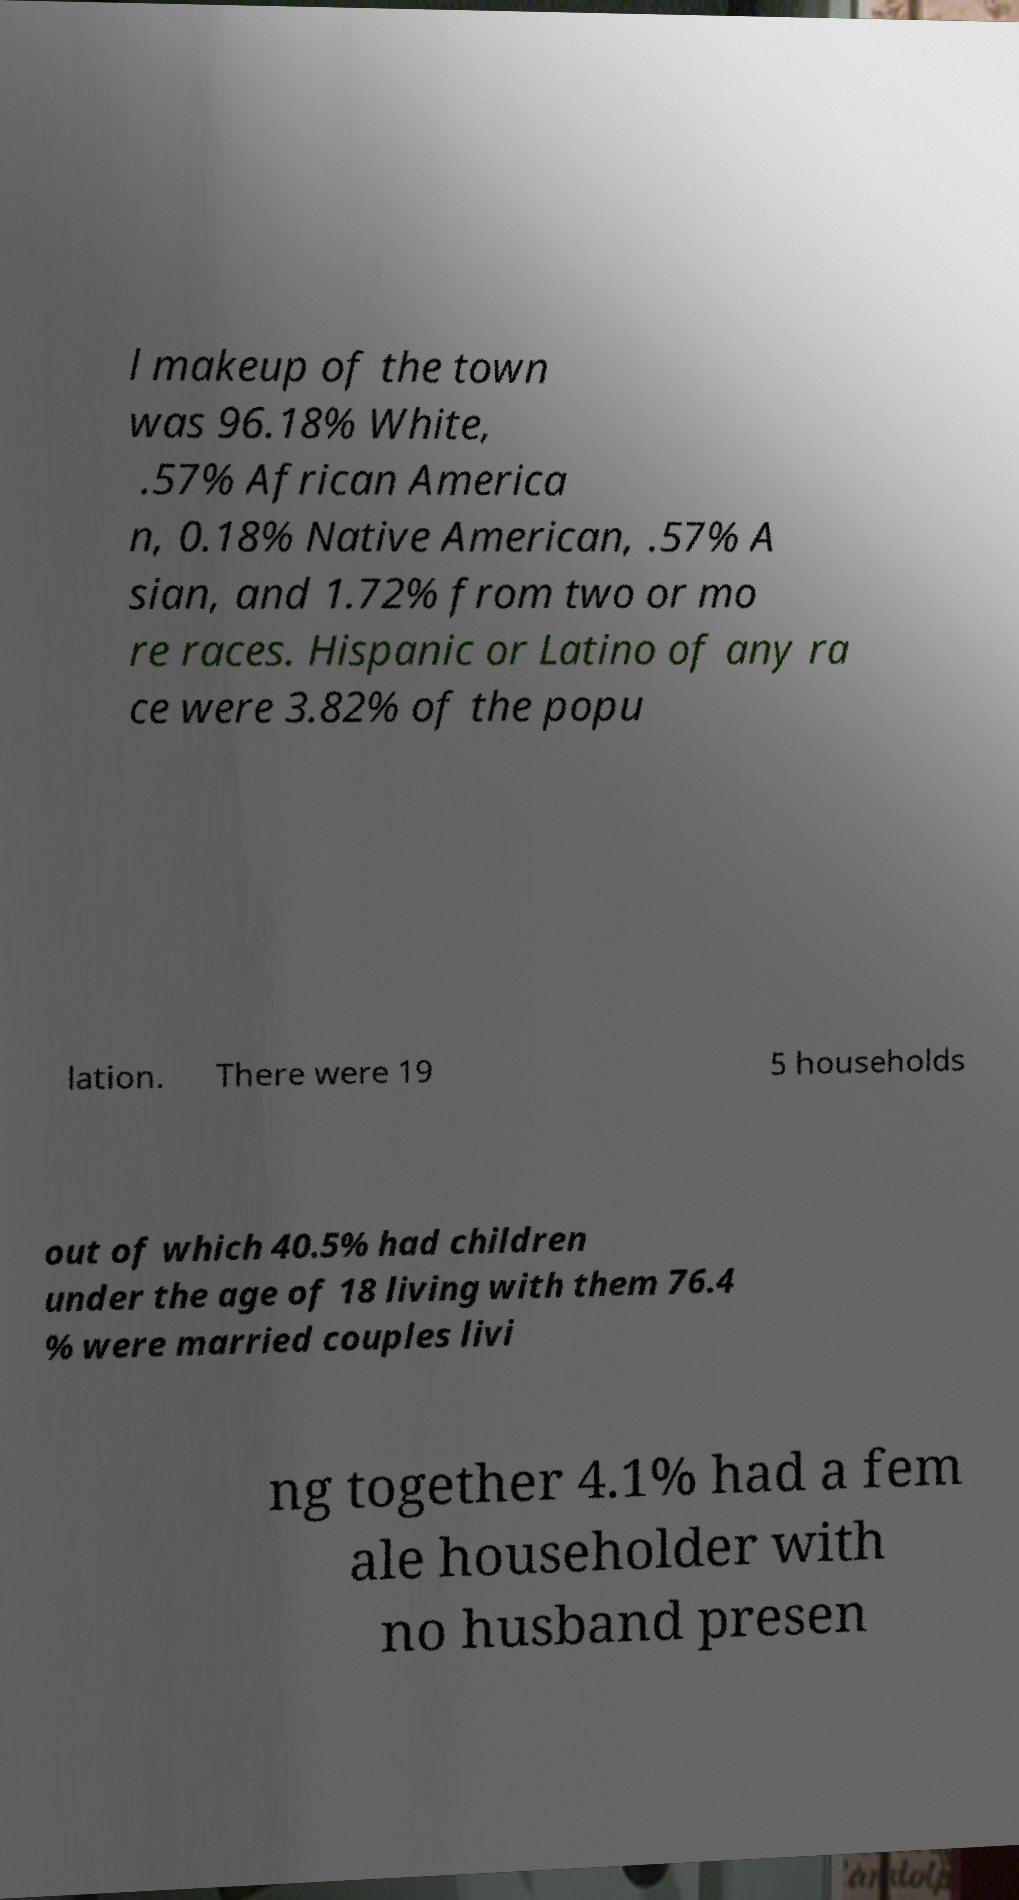I need the written content from this picture converted into text. Can you do that? l makeup of the town was 96.18% White, .57% African America n, 0.18% Native American, .57% A sian, and 1.72% from two or mo re races. Hispanic or Latino of any ra ce were 3.82% of the popu lation. There were 19 5 households out of which 40.5% had children under the age of 18 living with them 76.4 % were married couples livi ng together 4.1% had a fem ale householder with no husband presen 